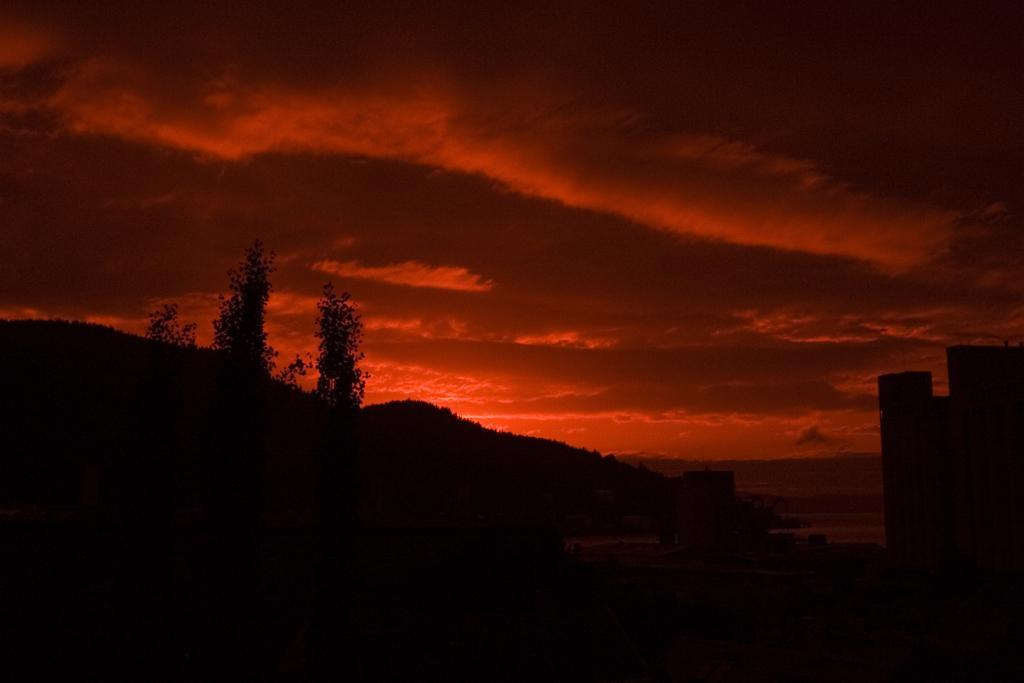In one or two sentences, can you explain what this image depicts? In this image in the front there are trees and in the background there are mountains and the sky is cloudy and reddish in colour. 